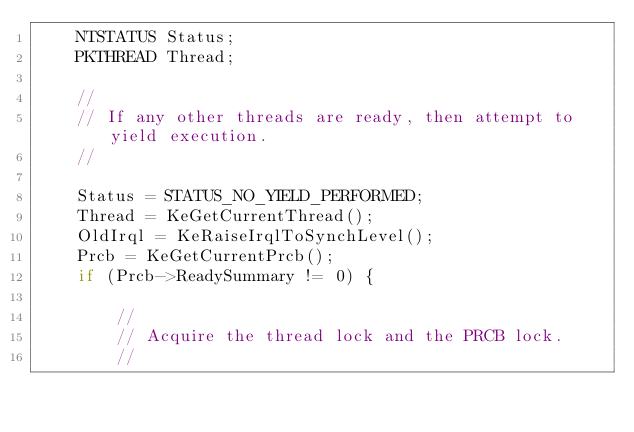<code> <loc_0><loc_0><loc_500><loc_500><_C_>    NTSTATUS Status;
    PKTHREAD Thread;

    //
    // If any other threads are ready, then attempt to yield execution.
    //

    Status = STATUS_NO_YIELD_PERFORMED;
    Thread = KeGetCurrentThread();
    OldIrql = KeRaiseIrqlToSynchLevel();
    Prcb = KeGetCurrentPrcb();
    if (Prcb->ReadySummary != 0) {

        //
        // Acquire the thread lock and the PRCB lock.
        //</code> 